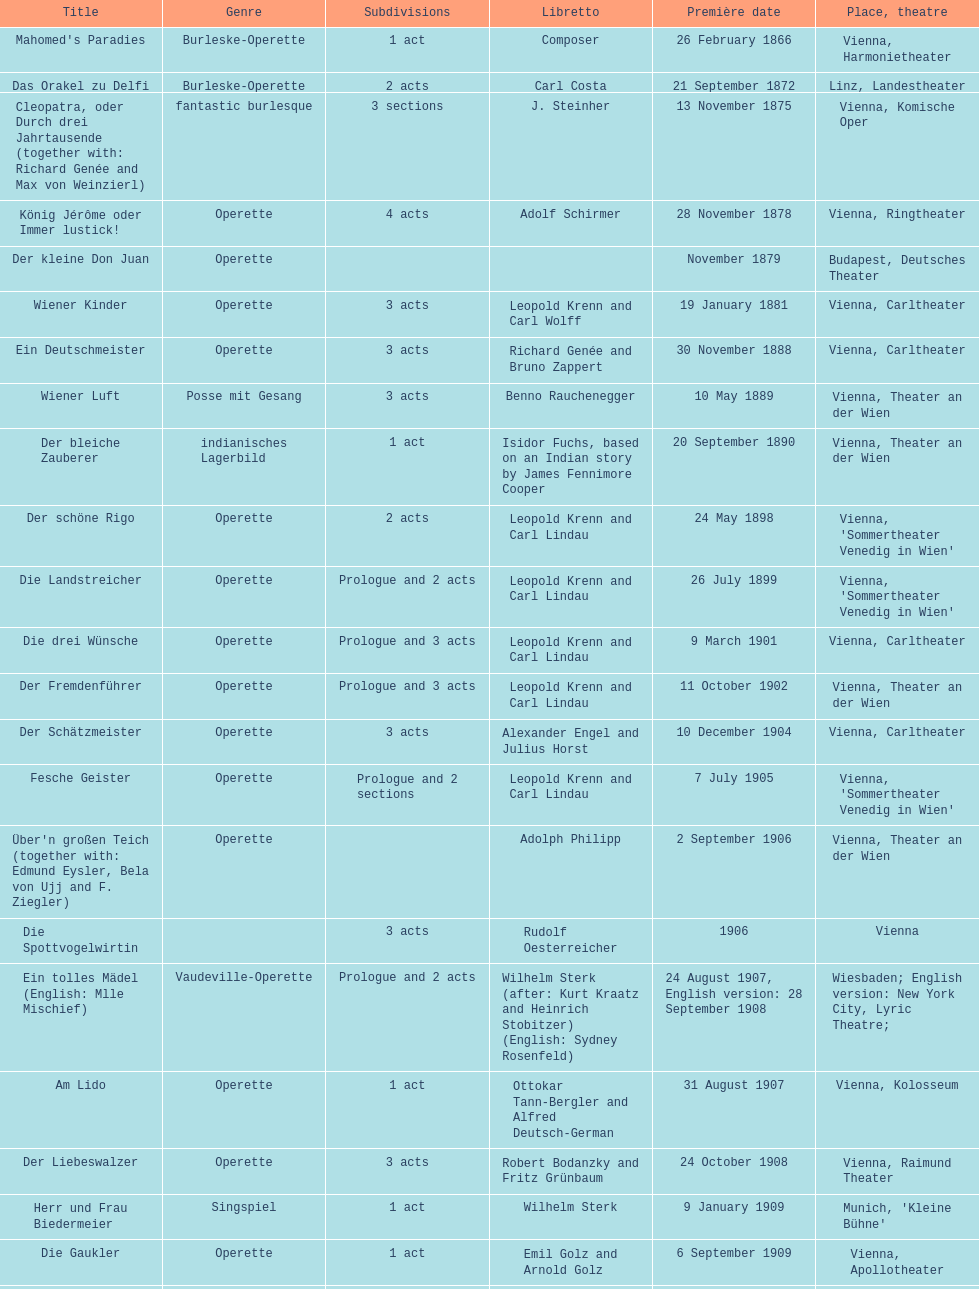Up to which year do all the dates go? 1958. 